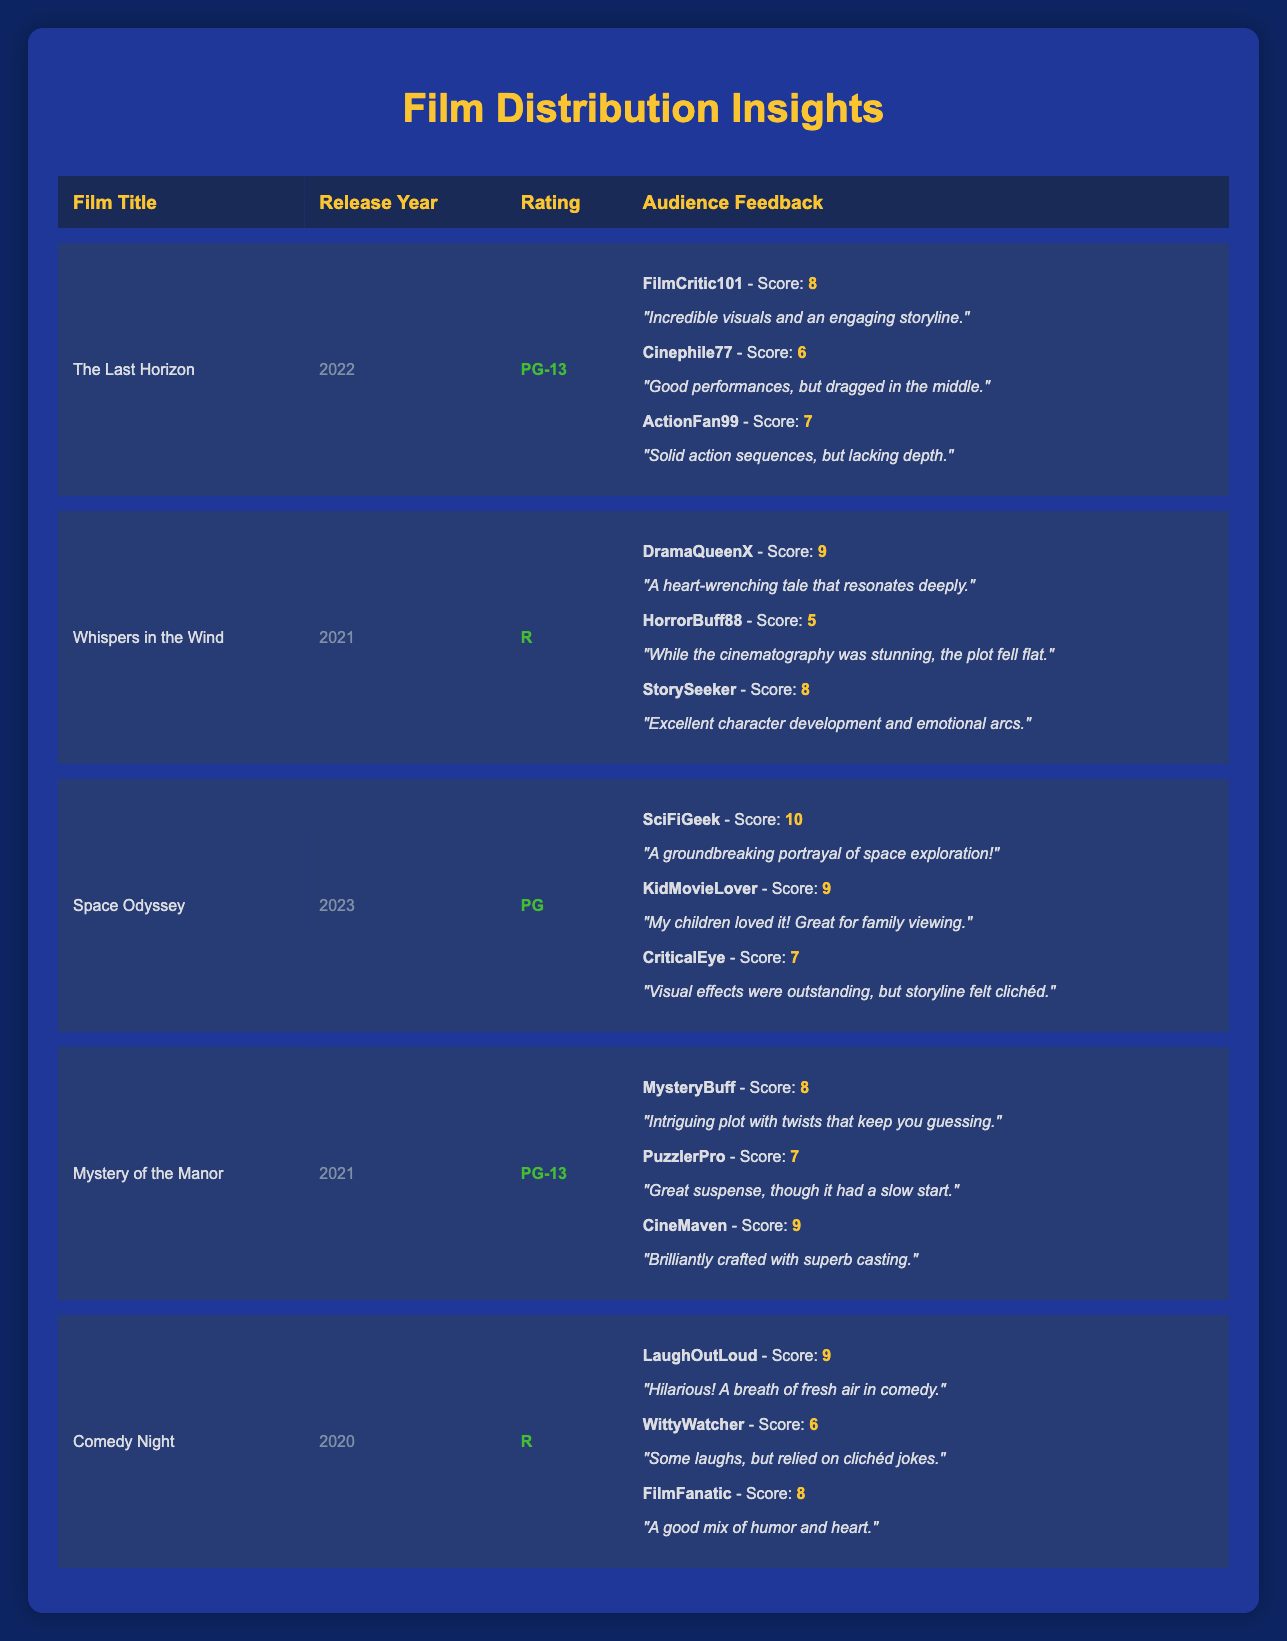What is the highest score given to "The Last Horizon"? The feedback reviews for "The Last Horizon" include scores of 8, 6, and 7. The highest score among these is 8, given by FilmCritic101.
Answer: 8 What year was "Whispers in the Wind" released? The table clearly states that "Whispers in the Wind" was released in 2021.
Answer: 2021 How many reviews scored above 8 for "Space Odyssey"? The reviews for "Space Odyssey" show scores of 10, 9, and 7. The scores above 8 are 10 and 9, which results in two scores above 8.
Answer: 2 Is it true that "Comedy Night" received a score of 10? Looking at the audience feedback for "Comedy Night", the scores provided are 9, 6, and 8. None of these scores is 10, thus the statement is false.
Answer: No What is the average score for films rated "R"? The films rated "R" are "Whispers in the Wind" (scores: 9, 5, 8) and "Comedy Night" (scores: 9, 6, 8). First, we find the sum of the scores: (9 + 5 + 8) + (9 + 6 + 8) = 53. There are 6 scores total, so the average score is 53 / 6 = approximately 8.83.
Answer: 8.83 Which film received the lowest score based on the audience feedback? The scores across all films include 8, 6, 7 for "The Last Horizon"; 9, 5, 8 for "Whispers in the Wind"; 10, 9, 7 for "Space Odyssey"; 8, 7, 9 for "Mystery of the Manor"; and 9, 6, 8 for "Comedy Night". The lowest score here is the 5 given by HorrorBuff88 for "Whispers in the Wind".
Answer: Whispers in the Wind What is the difference between the highest and lowest score received by "Mystery of the Manor"? For "Mystery of the Manor", the scores are 8, 7, and 9. The highest score is 9 and the lowest is 7. The difference is calculated as 9 - 7 = 2.
Answer: 2 Did "Space Odyssey" receive any reviews scoring below 8? The scores for "Space Odyssey" are 10, 9, and 7. Since one of the scores is 7, which is below 8, the statement is true.
Answer: Yes 